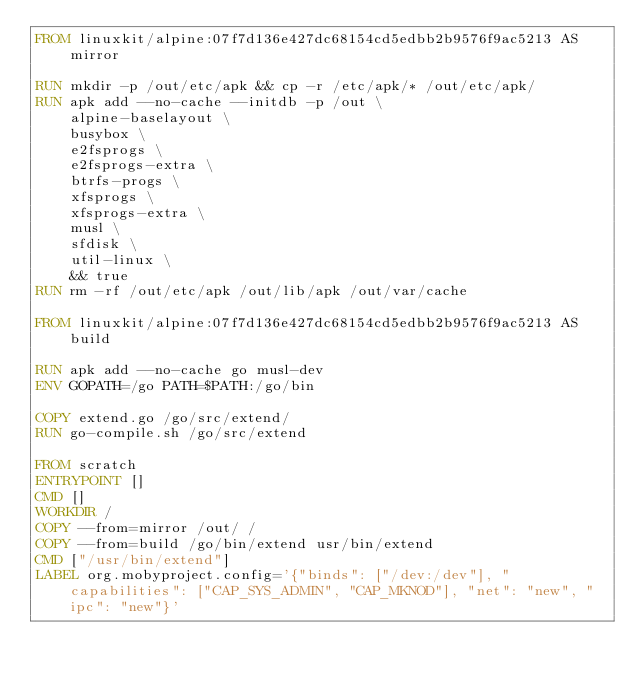<code> <loc_0><loc_0><loc_500><loc_500><_Dockerfile_>FROM linuxkit/alpine:07f7d136e427dc68154cd5edbb2b9576f9ac5213 AS mirror

RUN mkdir -p /out/etc/apk && cp -r /etc/apk/* /out/etc/apk/
RUN apk add --no-cache --initdb -p /out \
    alpine-baselayout \
    busybox \
    e2fsprogs \
    e2fsprogs-extra \
    btrfs-progs \
    xfsprogs \
    xfsprogs-extra \
    musl \
    sfdisk \
    util-linux \
    && true
RUN rm -rf /out/etc/apk /out/lib/apk /out/var/cache

FROM linuxkit/alpine:07f7d136e427dc68154cd5edbb2b9576f9ac5213 AS build

RUN apk add --no-cache go musl-dev
ENV GOPATH=/go PATH=$PATH:/go/bin

COPY extend.go /go/src/extend/
RUN go-compile.sh /go/src/extend

FROM scratch
ENTRYPOINT []
CMD []
WORKDIR /
COPY --from=mirror /out/ /
COPY --from=build /go/bin/extend usr/bin/extend
CMD ["/usr/bin/extend"]
LABEL org.mobyproject.config='{"binds": ["/dev:/dev"], "capabilities": ["CAP_SYS_ADMIN", "CAP_MKNOD"], "net": "new", "ipc": "new"}'
</code> 